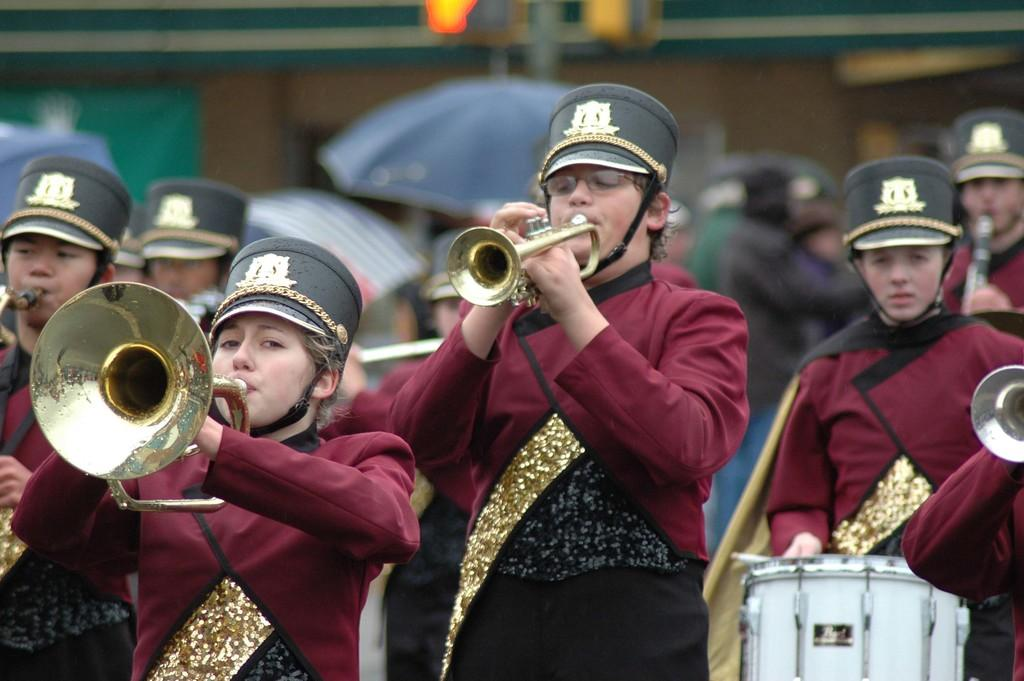What are the people in the image doing? The people in the image are playing musical instruments. Can you describe the background of the image? The background of the image is blurry. Can you see the moon in the image? There is no moon visible in the image; the focus is on the people playing musical instruments and the blurry background. 